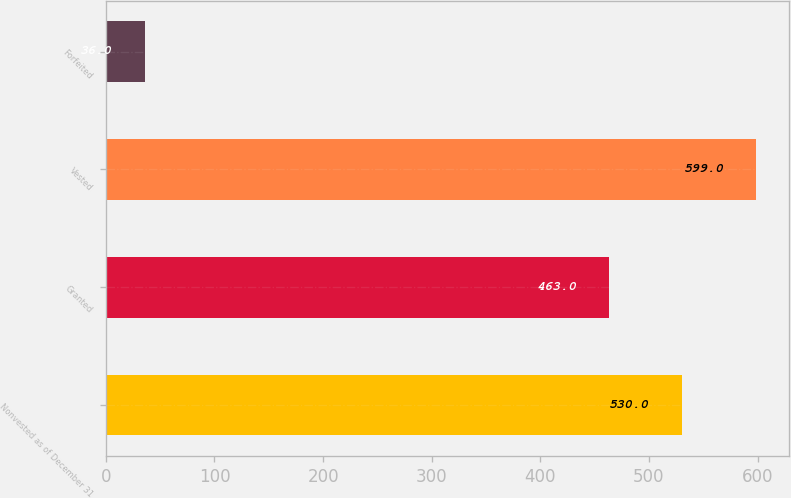Convert chart to OTSL. <chart><loc_0><loc_0><loc_500><loc_500><bar_chart><fcel>Nonvested as of December 31<fcel>Granted<fcel>Vested<fcel>Forfeited<nl><fcel>530<fcel>463<fcel>599<fcel>36<nl></chart> 